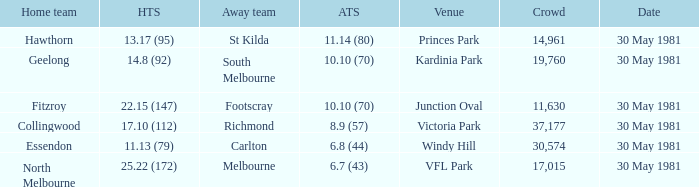What is the home venue of essendon with a crowd larger than 19,760? Windy Hill. 